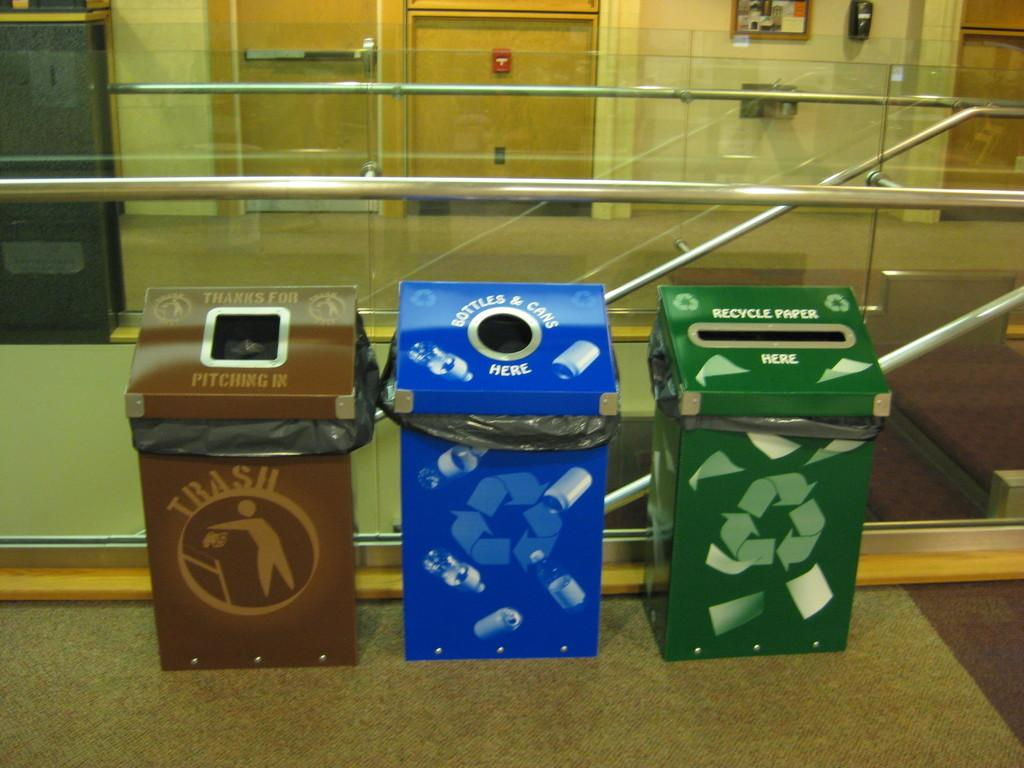<image>
Present a compact description of the photo's key features. A trash bin, and two recycling bins are in a line next to each other. 